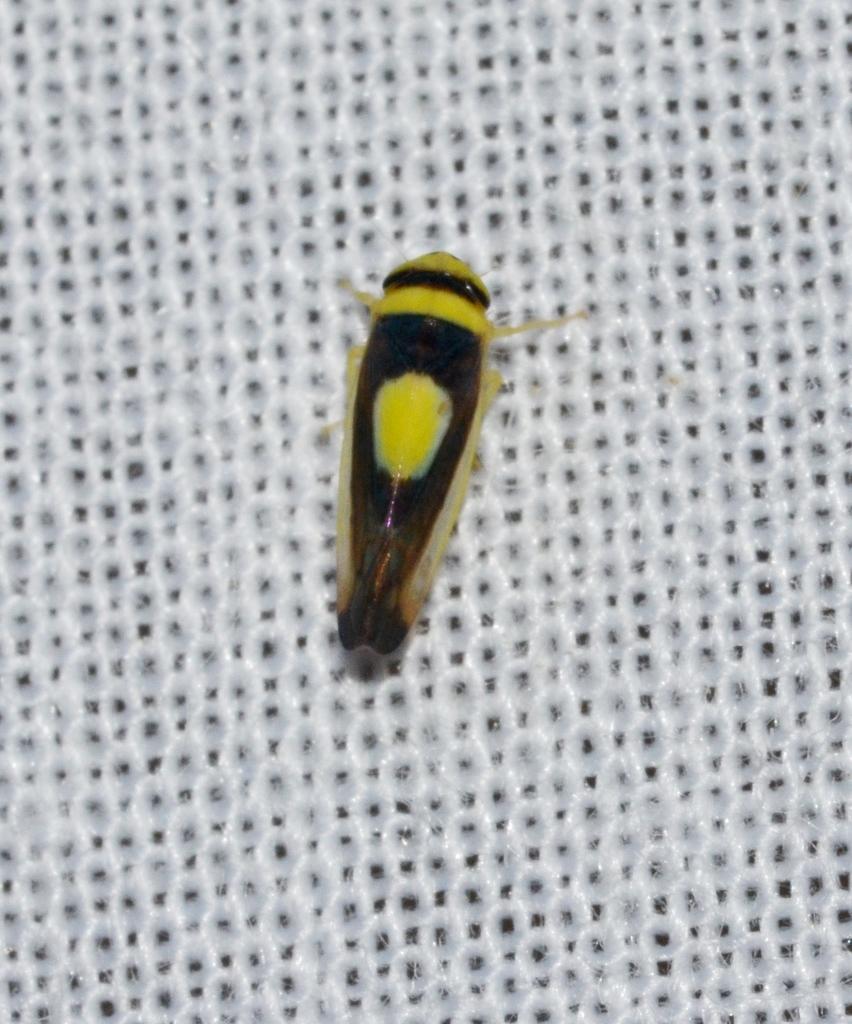Can you describe this image briefly? In this image I can see an insect in the middle of the white mesh. 